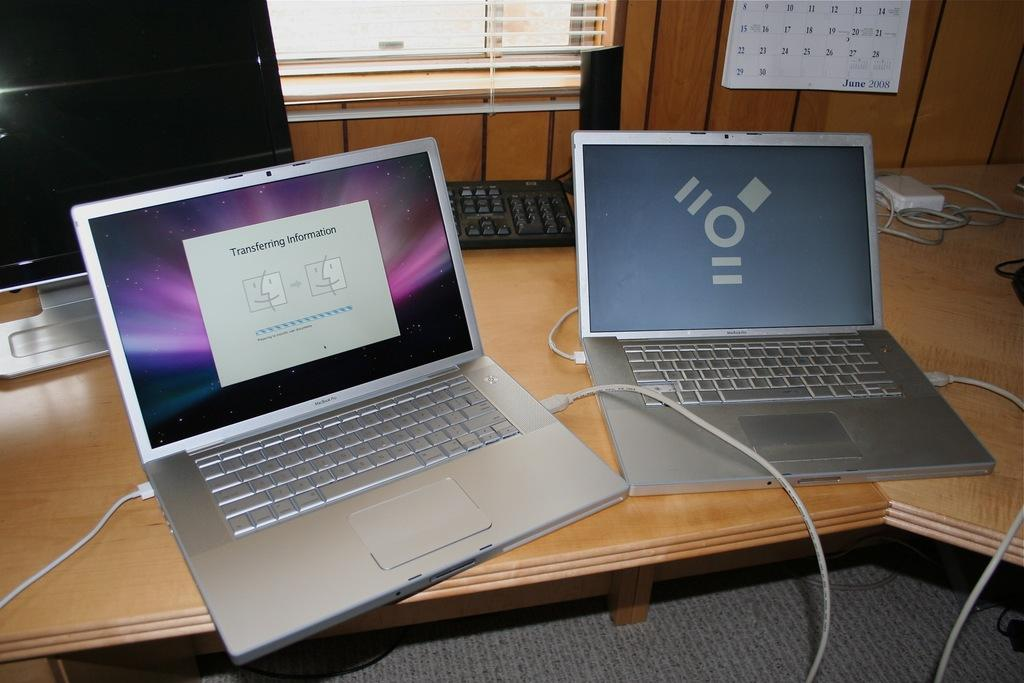<image>
Provide a brief description of the given image. A pop up screen on a computer notifies of the transfer of information. 